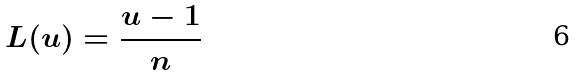<formula> <loc_0><loc_0><loc_500><loc_500>L ( u ) = \frac { u - 1 } { n }</formula> 